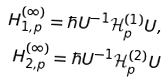Convert formula to latex. <formula><loc_0><loc_0><loc_500><loc_500>H ^ { ( \infty ) } _ { 1 , p } = \hbar { U } ^ { - 1 } \mathcal { H } ^ { ( 1 ) } _ { p } U , \\ H ^ { ( \infty ) } _ { 2 , p } = \hbar { U } ^ { - 1 } \mathcal { H } ^ { ( 2 ) } _ { p } U</formula> 